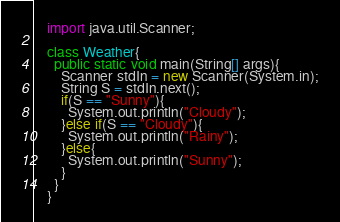<code> <loc_0><loc_0><loc_500><loc_500><_Java_>    import java.util.Scanner;
     
    class Weather{
      public static void main(String[] args){
        Scanner stdIn = new Scanner(System.in);
        String S = stdIn.next();
        if(S == "Sunny"){
          System.out.println("Cloudy");
        }else if(S == "Cloudy"){
          System.out.println("Rainy");
        }else{
          System.out.println("Sunny");
        }
      }
    }</code> 